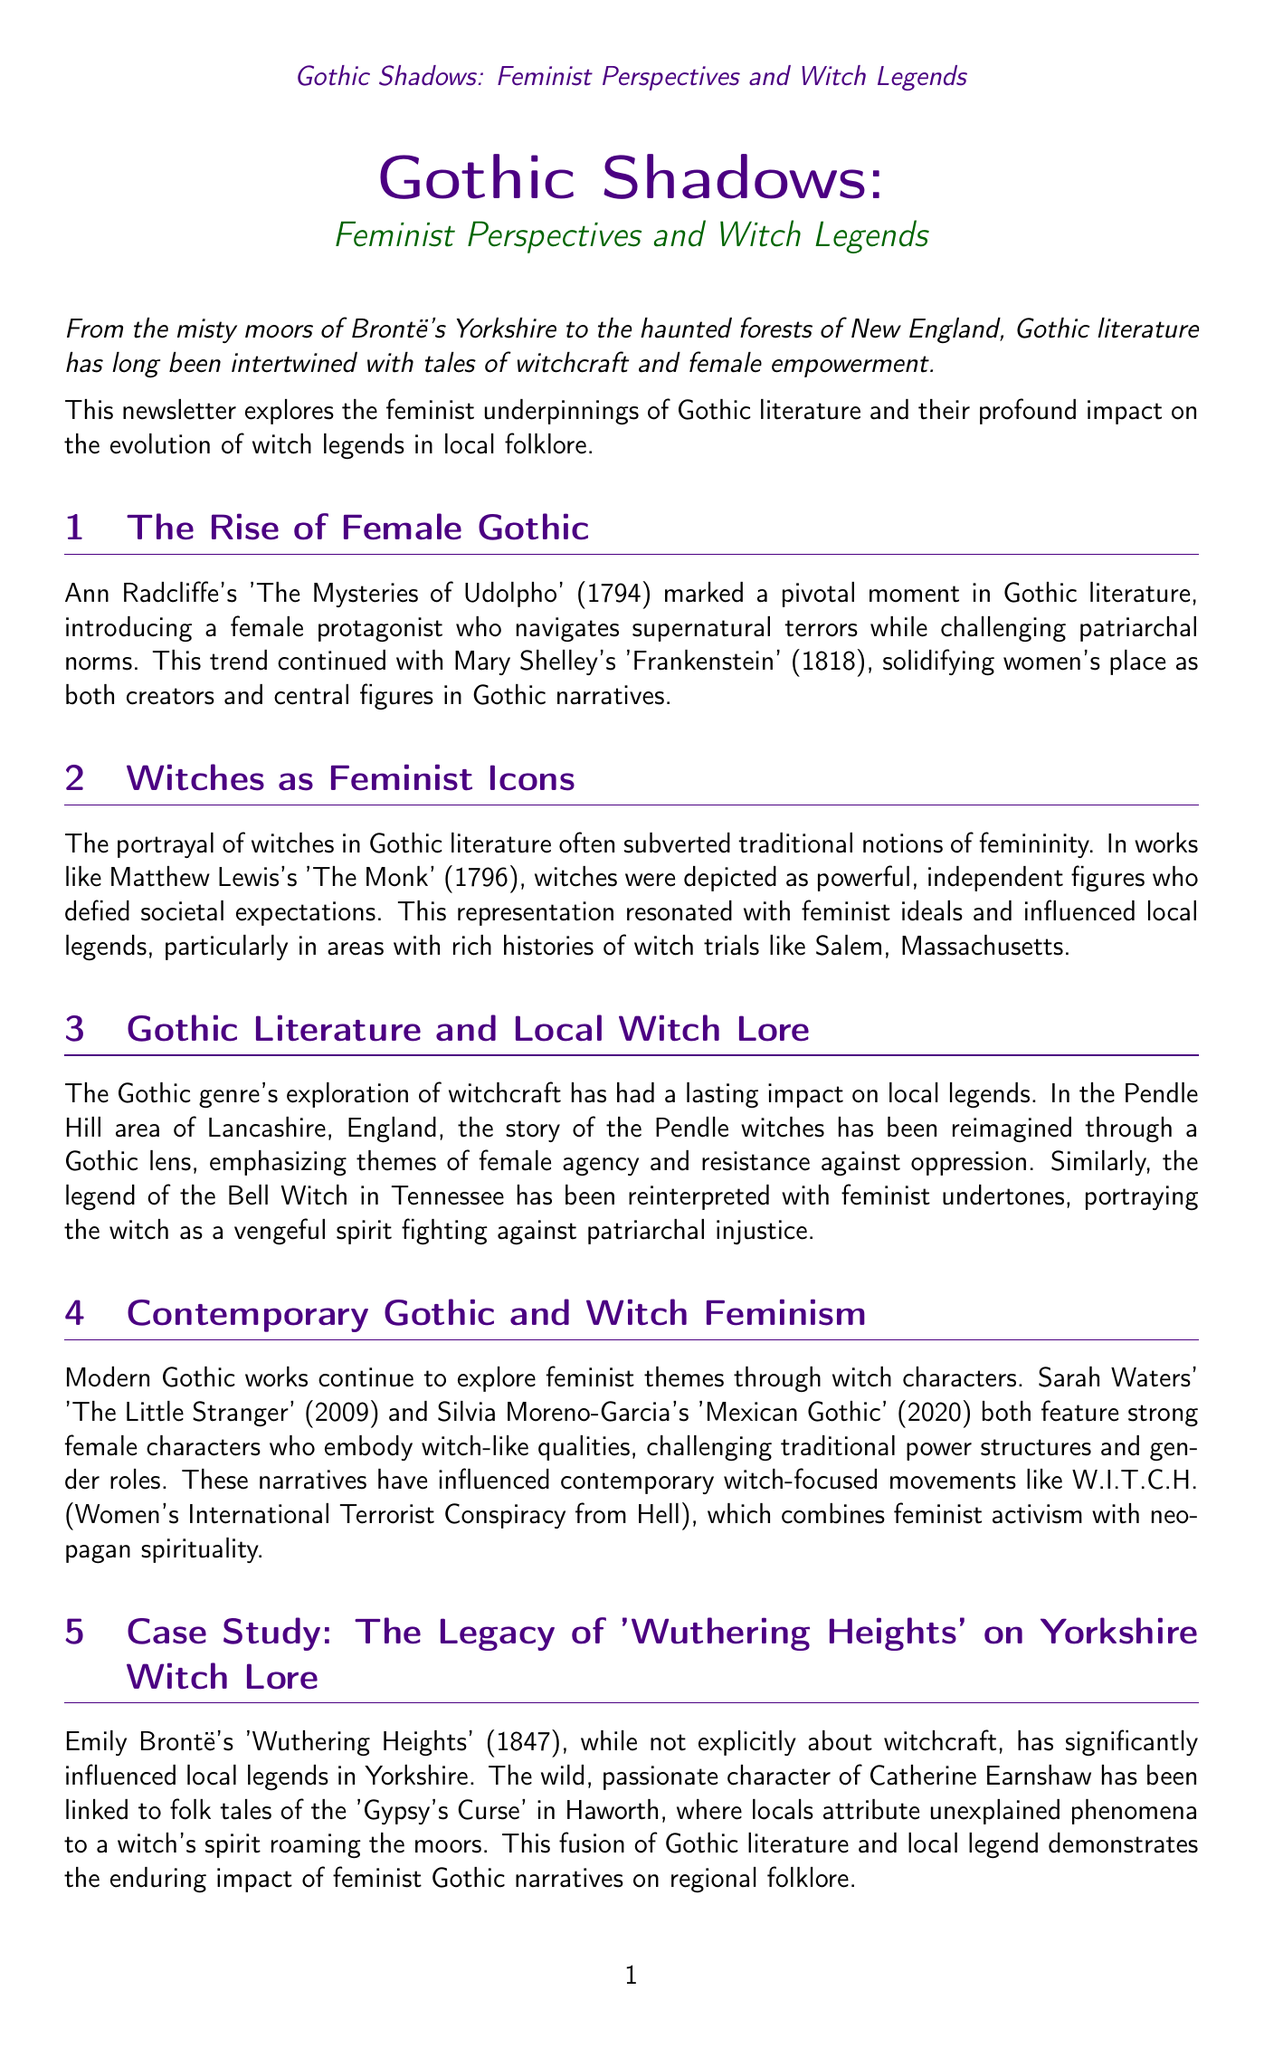what is the title of the newsletter? The title is presented at the beginning of the document and is "Gothic Shadows: Feminist Perspectives and Witch Legends."
Answer: Gothic Shadows: Feminist Perspectives and Witch Legends who authored "The Mysteries of Udolpho"? The document states that Ann Radcliffe authored "The Mysteries of Udolpho."
Answer: Ann Radcliffe which character is linked to the 'Gypsy's Curse'? The character linked to the 'Gypsy's Curse' is Catherine Earnshaw from "Wuthering Heights."
Answer: Catherine Earnshaw what year was "Wuthering Heights" published? The publication year of "Wuthering Heights," as mentioned in the document, is 1847.
Answer: 1847 which area is associated with the Pendle witches? The document mentions that the Pendle witches are associated with the Pendle Hill area.
Answer: Pendle Hill what feminist movement is influenced by modern Gothic works? The document states that contemporary Gothic narratives have influenced the W.I.T.C.H. movement.
Answer: W.I.T.C.H what is the primary theme discussed in the conclusion? The conclusion summarizes the transformation of witch legends from fear to empowerment, a primary theme discussed.
Answer: female empowerment which book is recommended for further reading on Gothic literature? The document lists "Women and the Gothic: An Edinburgh Companion" as a recommended book.
Answer: Women and the Gothic: An Edinburgh Companion what is the publication year of the article by Emma Young? The document states that the article by Emma Young was published in 2019.
Answer: 2019 